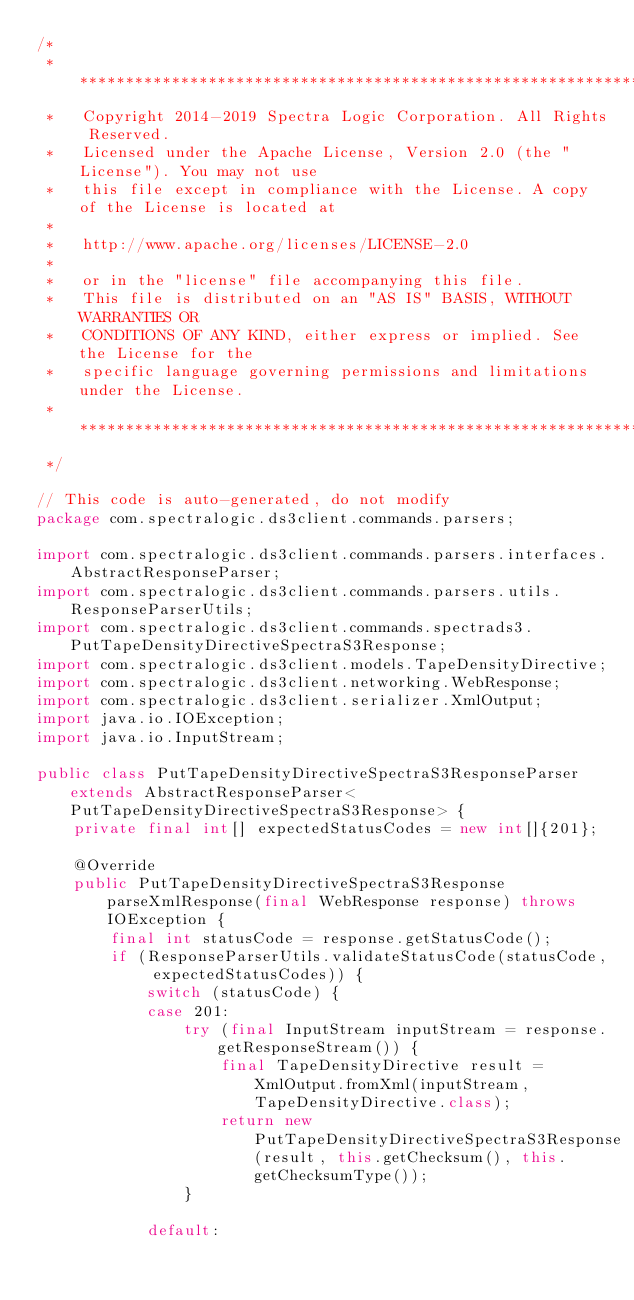<code> <loc_0><loc_0><loc_500><loc_500><_Java_>/*
 * ******************************************************************************
 *   Copyright 2014-2019 Spectra Logic Corporation. All Rights Reserved.
 *   Licensed under the Apache License, Version 2.0 (the "License"). You may not use
 *   this file except in compliance with the License. A copy of the License is located at
 *
 *   http://www.apache.org/licenses/LICENSE-2.0
 *
 *   or in the "license" file accompanying this file.
 *   This file is distributed on an "AS IS" BASIS, WITHOUT WARRANTIES OR
 *   CONDITIONS OF ANY KIND, either express or implied. See the License for the
 *   specific language governing permissions and limitations under the License.
 * ****************************************************************************
 */

// This code is auto-generated, do not modify
package com.spectralogic.ds3client.commands.parsers;

import com.spectralogic.ds3client.commands.parsers.interfaces.AbstractResponseParser;
import com.spectralogic.ds3client.commands.parsers.utils.ResponseParserUtils;
import com.spectralogic.ds3client.commands.spectrads3.PutTapeDensityDirectiveSpectraS3Response;
import com.spectralogic.ds3client.models.TapeDensityDirective;
import com.spectralogic.ds3client.networking.WebResponse;
import com.spectralogic.ds3client.serializer.XmlOutput;
import java.io.IOException;
import java.io.InputStream;

public class PutTapeDensityDirectiveSpectraS3ResponseParser extends AbstractResponseParser<PutTapeDensityDirectiveSpectraS3Response> {
    private final int[] expectedStatusCodes = new int[]{201};

    @Override
    public PutTapeDensityDirectiveSpectraS3Response parseXmlResponse(final WebResponse response) throws IOException {
        final int statusCode = response.getStatusCode();
        if (ResponseParserUtils.validateStatusCode(statusCode, expectedStatusCodes)) {
            switch (statusCode) {
            case 201:
                try (final InputStream inputStream = response.getResponseStream()) {
                    final TapeDensityDirective result = XmlOutput.fromXml(inputStream, TapeDensityDirective.class);
                    return new PutTapeDensityDirectiveSpectraS3Response(result, this.getChecksum(), this.getChecksumType());
                }

            default:</code> 